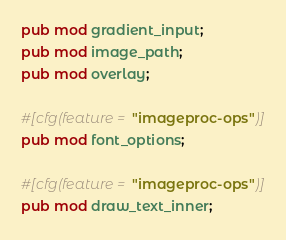<code> <loc_0><loc_0><loc_500><loc_500><_Rust_>pub mod gradient_input;
pub mod image_path;
pub mod overlay;

#[cfg(feature = "imageproc-ops")]
pub mod font_options;

#[cfg(feature = "imageproc-ops")]
pub mod draw_text_inner;
</code> 